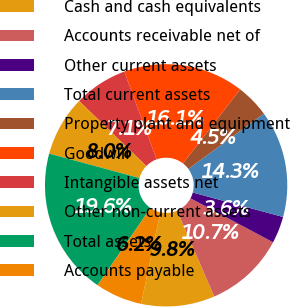Convert chart to OTSL. <chart><loc_0><loc_0><loc_500><loc_500><pie_chart><fcel>Cash and cash equivalents<fcel>Accounts receivable net of<fcel>Other current assets<fcel>Total current assets<fcel>Property plant and equipment<fcel>Goodwill<fcel>Intangible assets net<fcel>Other non-current assets<fcel>Total assets<fcel>Accounts payable<nl><fcel>9.82%<fcel>10.71%<fcel>3.58%<fcel>14.28%<fcel>4.47%<fcel>16.07%<fcel>7.14%<fcel>8.04%<fcel>19.64%<fcel>6.25%<nl></chart> 